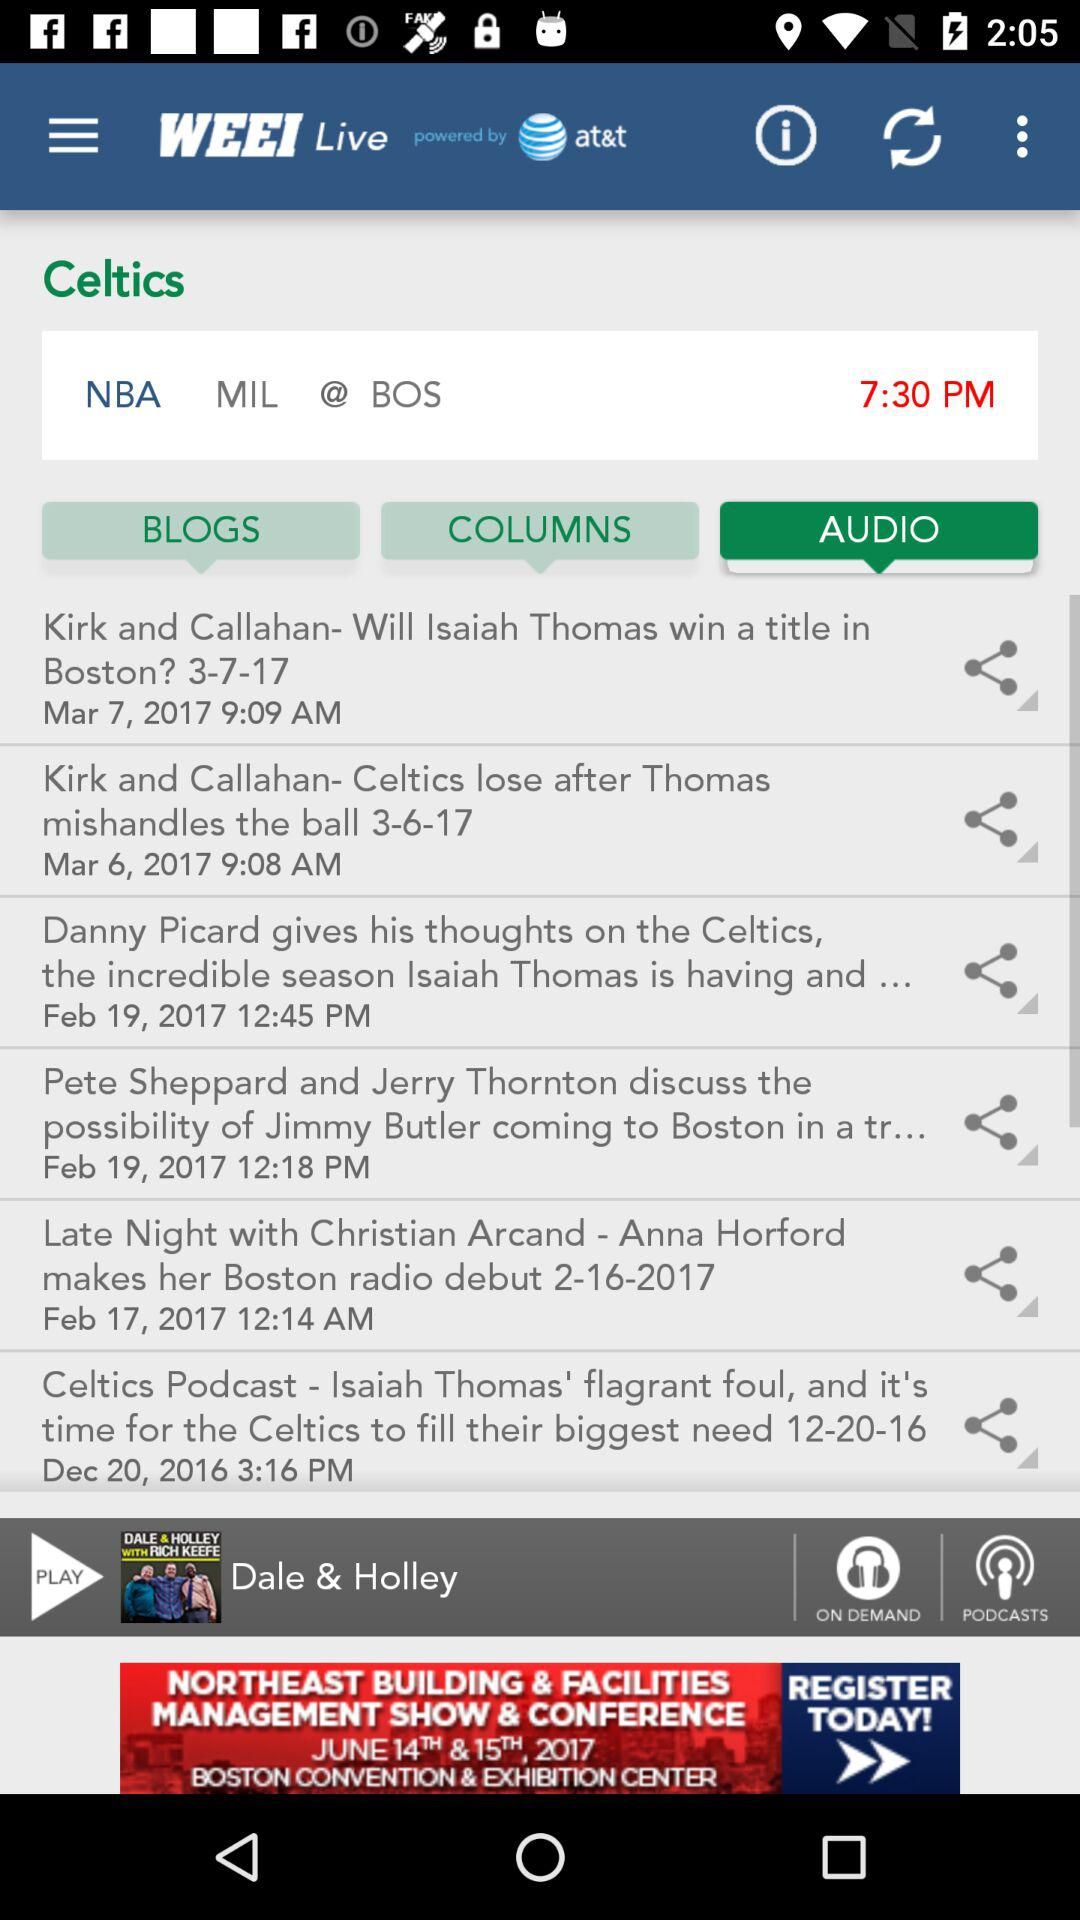How long is "Dale & Holley"?
When the provided information is insufficient, respond with <no answer>. <no answer> 